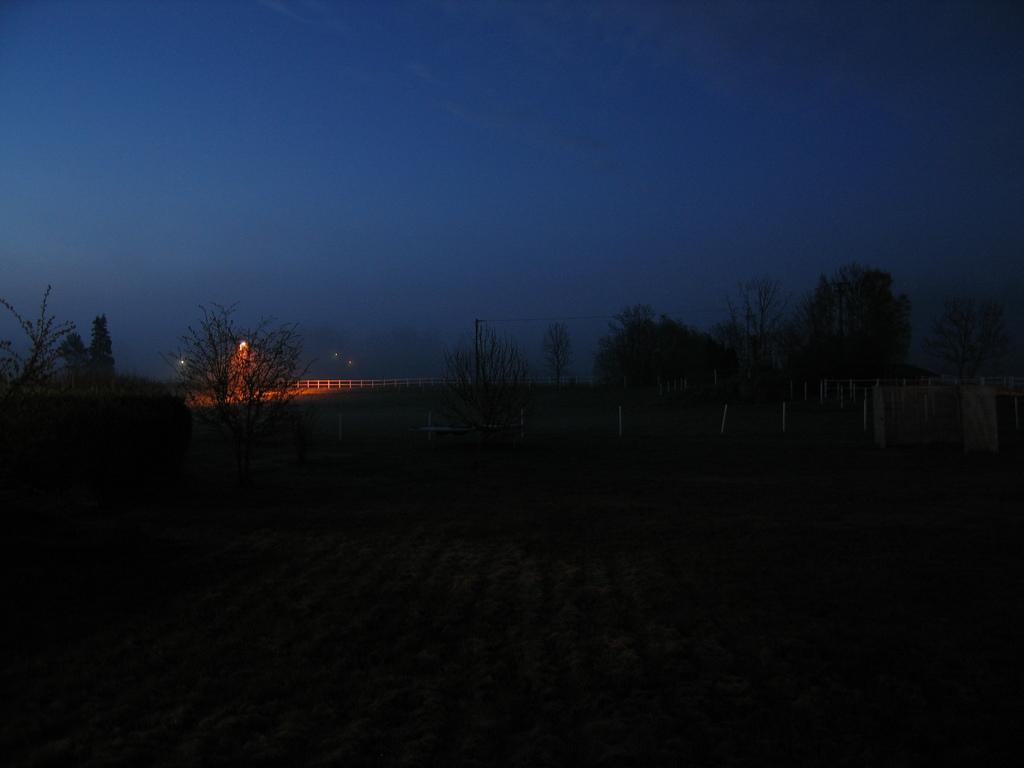Could you give a brief overview of what you see in this image? In this image I can see many trees, railing and the light. And there is a sky in the back. 